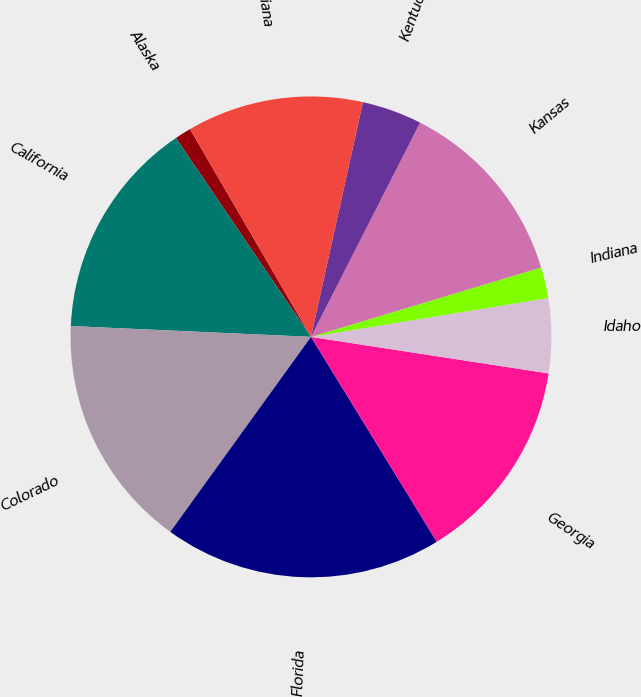Convert chart. <chart><loc_0><loc_0><loc_500><loc_500><pie_chart><fcel>Alaska<fcel>California<fcel>Colorado<fcel>Florida<fcel>Georgia<fcel>Idaho<fcel>Indiana<fcel>Kansas<fcel>Kentucky<fcel>Louisiana<nl><fcel>1.1%<fcel>14.79%<fcel>15.77%<fcel>18.71%<fcel>13.81%<fcel>5.01%<fcel>2.08%<fcel>12.84%<fcel>4.03%<fcel>11.86%<nl></chart> 